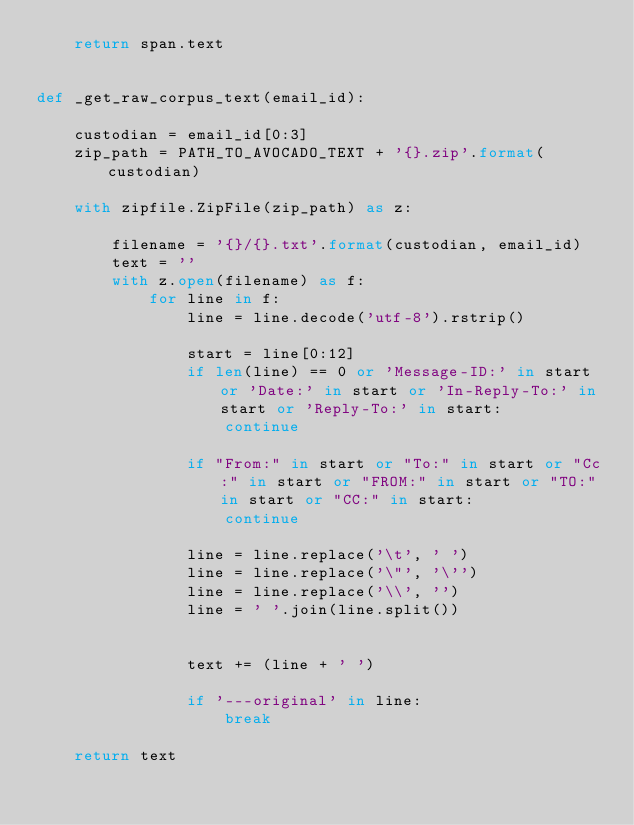Convert code to text. <code><loc_0><loc_0><loc_500><loc_500><_Python_>    return span.text


def _get_raw_corpus_text(email_id):

    custodian = email_id[0:3]
    zip_path = PATH_TO_AVOCADO_TEXT + '{}.zip'.format(custodian)

    with zipfile.ZipFile(zip_path) as z:

        filename = '{}/{}.txt'.format(custodian, email_id)
        text = ''
        with z.open(filename) as f:
            for line in f:
                line = line.decode('utf-8').rstrip()

                start = line[0:12]
                if len(line) == 0 or 'Message-ID:' in start or 'Date:' in start or 'In-Reply-To:' in start or 'Reply-To:' in start:
                    continue

                if "From:" in start or "To:" in start or "Cc:" in start or "FROM:" in start or "TO:" in start or "CC:" in start:
                    continue

                line = line.replace('\t', ' ')
                line = line.replace('\"', '\'')
                line = line.replace('\\', '')
                line = ' '.join(line.split())


                text += (line + ' ')

                if '---original' in line:
                    break

    return text
</code> 